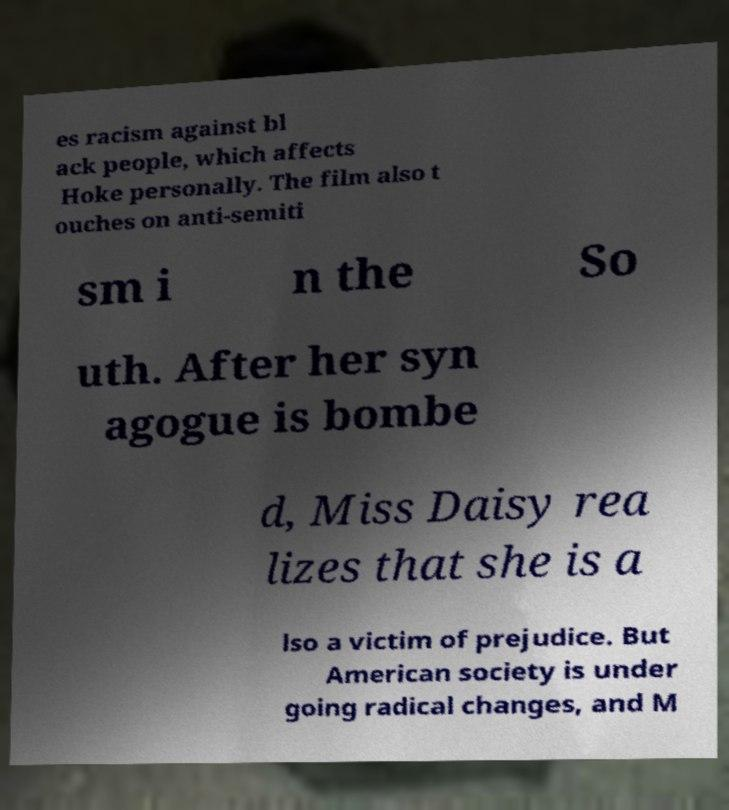Please identify and transcribe the text found in this image. es racism against bl ack people, which affects Hoke personally. The film also t ouches on anti-semiti sm i n the So uth. After her syn agogue is bombe d, Miss Daisy rea lizes that she is a lso a victim of prejudice. But American society is under going radical changes, and M 